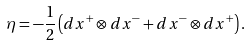<formula> <loc_0><loc_0><loc_500><loc_500>\eta = - \frac { 1 } { 2 } \left ( d x ^ { + } \otimes d x ^ { - } + d x ^ { - } \otimes d x ^ { + } \right ) .</formula> 